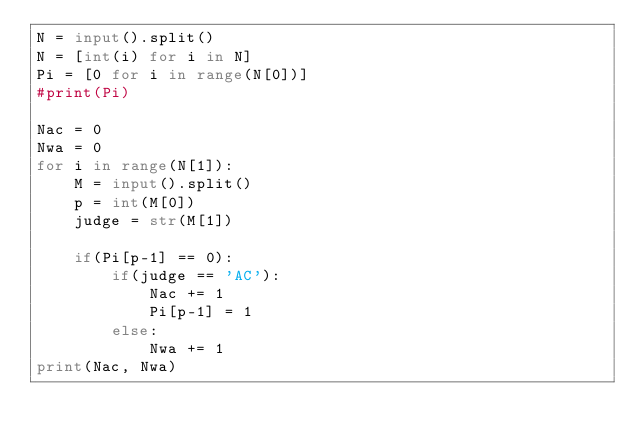<code> <loc_0><loc_0><loc_500><loc_500><_Python_>N = input().split()
N = [int(i) for i in N]
Pi = [0 for i in range(N[0])]
#print(Pi)

Nac = 0
Nwa = 0
for i in range(N[1]):
    M = input().split()
    p = int(M[0])
    judge = str(M[1])

    if(Pi[p-1] == 0):
        if(judge == 'AC'):
            Nac += 1
            Pi[p-1] = 1
        else:
            Nwa += 1
print(Nac, Nwa)
    
</code> 